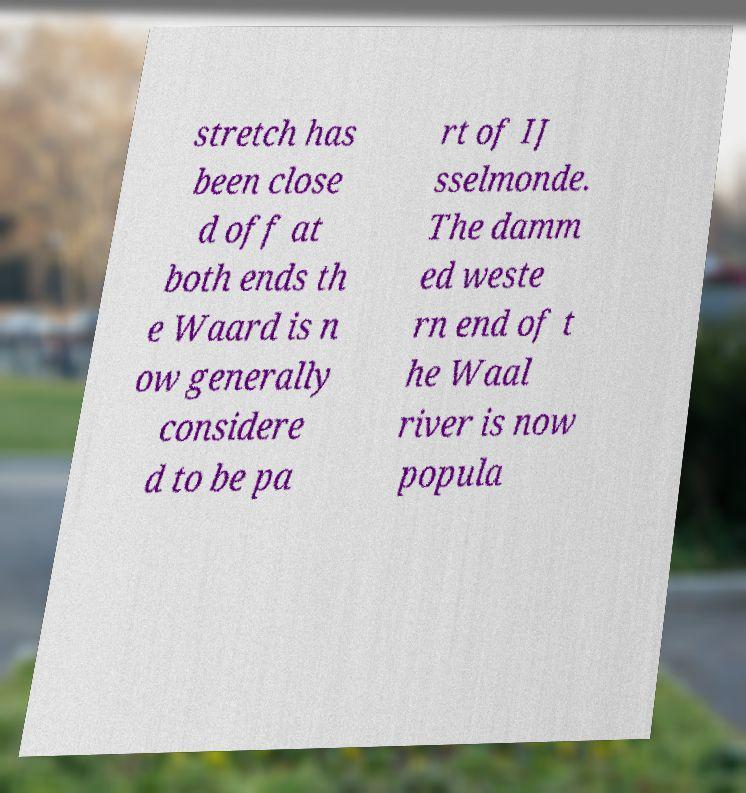Can you read and provide the text displayed in the image?This photo seems to have some interesting text. Can you extract and type it out for me? stretch has been close d off at both ends th e Waard is n ow generally considere d to be pa rt of IJ sselmonde. The damm ed weste rn end of t he Waal river is now popula 